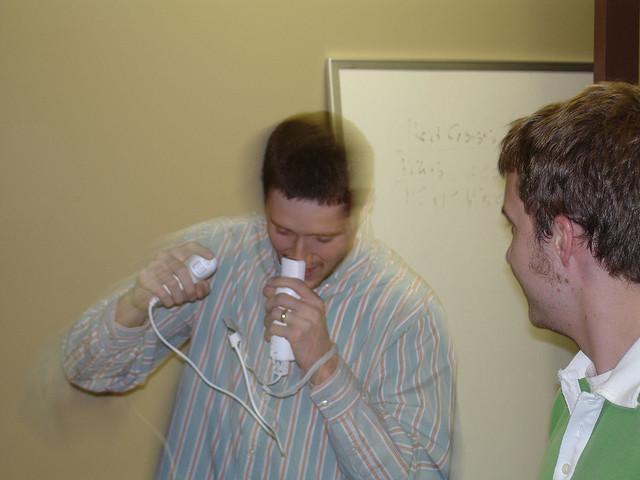How many people can you see?
Give a very brief answer. 2. 